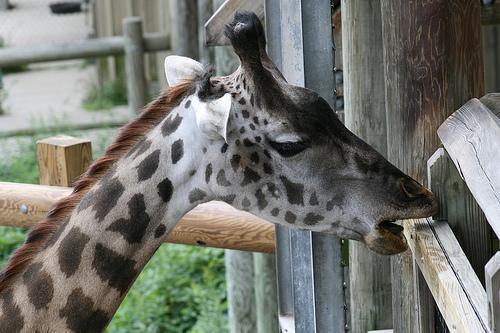How many giraffes are visible?
Give a very brief answer. 1. 